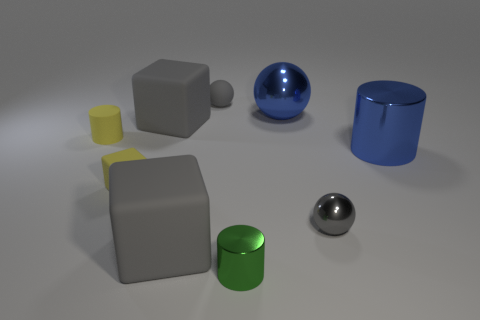Add 1 big purple shiny cylinders. How many objects exist? 10 Subtract all cubes. How many objects are left? 6 Add 1 small shiny objects. How many small shiny objects are left? 3 Add 3 tiny blocks. How many tiny blocks exist? 4 Subtract 1 gray spheres. How many objects are left? 8 Subtract all green metal things. Subtract all tiny objects. How many objects are left? 3 